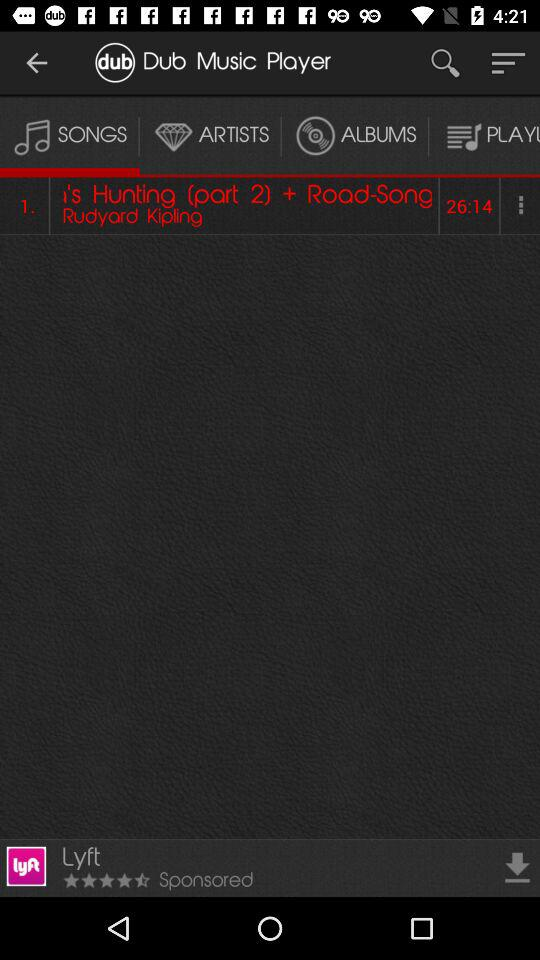Which tab has been selected? The tab "SONGS" has been selected. 